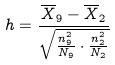Convert formula to latex. <formula><loc_0><loc_0><loc_500><loc_500>h = \frac { \overline { X } _ { 9 } - \overline { X } _ { 2 } } { \sqrt { \frac { n _ { 9 } ^ { 2 } } { N _ { 9 } } \cdot \frac { n _ { 2 } ^ { 2 } } { N _ { 2 } } } }</formula> 